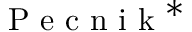Convert formula to latex. <formula><loc_0><loc_0><loc_500><loc_500>P e c n i k ^ { * }</formula> 